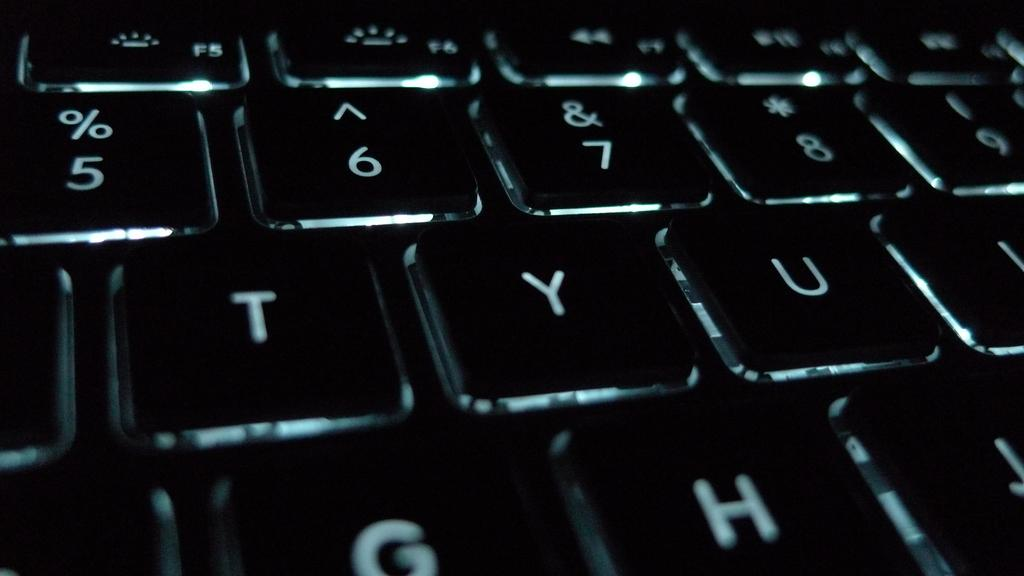<image>
Describe the image concisely. The letter keys "t,", "y","u", "g", and "h" are featured. 